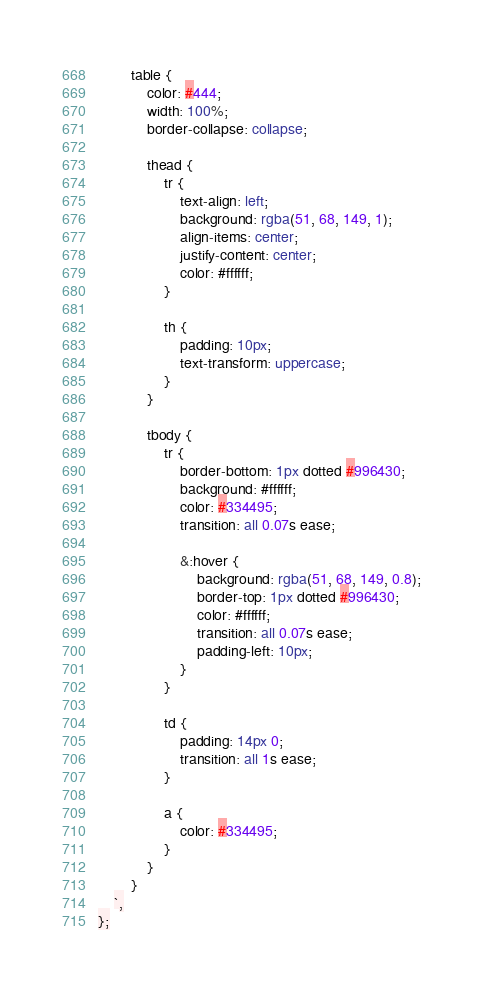Convert code to text. <code><loc_0><loc_0><loc_500><loc_500><_TypeScript_>        table {
            color: #444;
            width: 100%;
            border-collapse: collapse;

            thead {
                tr {
                    text-align: left;
                    background: rgba(51, 68, 149, 1);
                    align-items: center;
                    justify-content: center;
                    color: #ffffff;
                }

                th {
                    padding: 10px;
                    text-transform: uppercase;
                }
            }

            tbody {
                tr {
                    border-bottom: 1px dotted #996430;
                    background: #ffffff;
                    color: #334495;
                    transition: all 0.07s ease;

                    &:hover {
                        background: rgba(51, 68, 149, 0.8);
                        border-top: 1px dotted #996430;
                        color: #ffffff;
                        transition: all 0.07s ease;
                        padding-left: 10px;
                    }
                }

                td {
                    padding: 14px 0;
                    transition: all 1s ease;
                }

                a {
                    color: #334495;
                }
            }
        }
    `,
};
</code> 